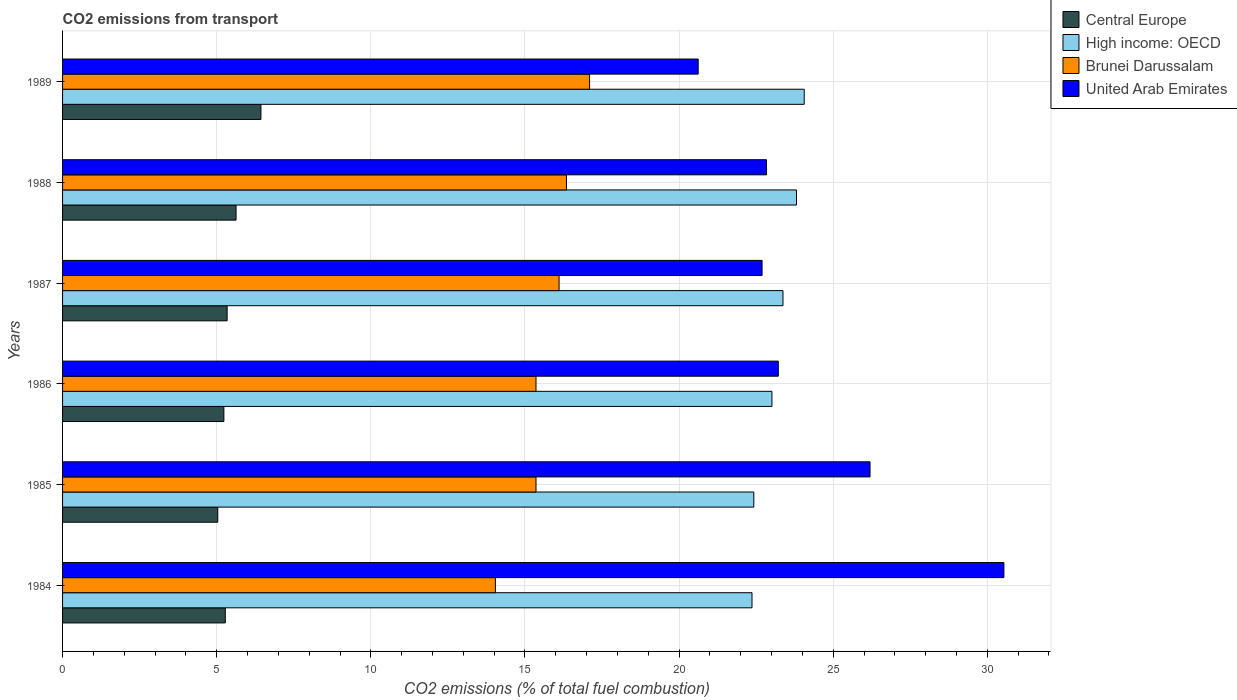How many groups of bars are there?
Make the answer very short. 6. How many bars are there on the 2nd tick from the top?
Your response must be concise. 4. In how many cases, is the number of bars for a given year not equal to the number of legend labels?
Your answer should be very brief. 0. What is the total CO2 emitted in Brunei Darussalam in 1984?
Give a very brief answer. 14.04. Across all years, what is the maximum total CO2 emitted in United Arab Emirates?
Offer a terse response. 30.54. Across all years, what is the minimum total CO2 emitted in High income: OECD?
Keep it short and to the point. 22.37. In which year was the total CO2 emitted in United Arab Emirates minimum?
Offer a terse response. 1989. What is the total total CO2 emitted in Central Europe in the graph?
Provide a succinct answer. 32.95. What is the difference between the total CO2 emitted in United Arab Emirates in 1985 and that in 1989?
Your answer should be very brief. 5.57. What is the difference between the total CO2 emitted in United Arab Emirates in 1988 and the total CO2 emitted in Brunei Darussalam in 1989?
Make the answer very short. 5.74. What is the average total CO2 emitted in Central Europe per year?
Give a very brief answer. 5.49. In the year 1986, what is the difference between the total CO2 emitted in Central Europe and total CO2 emitted in High income: OECD?
Your answer should be compact. -17.78. In how many years, is the total CO2 emitted in United Arab Emirates greater than 20 ?
Your answer should be compact. 6. What is the ratio of the total CO2 emitted in High income: OECD in 1984 to that in 1988?
Keep it short and to the point. 0.94. Is the total CO2 emitted in United Arab Emirates in 1985 less than that in 1987?
Your response must be concise. No. Is the difference between the total CO2 emitted in Central Europe in 1984 and 1988 greater than the difference between the total CO2 emitted in High income: OECD in 1984 and 1988?
Provide a short and direct response. Yes. What is the difference between the highest and the second highest total CO2 emitted in United Arab Emirates?
Provide a short and direct response. 4.34. What is the difference between the highest and the lowest total CO2 emitted in Central Europe?
Provide a succinct answer. 1.4. In how many years, is the total CO2 emitted in Central Europe greater than the average total CO2 emitted in Central Europe taken over all years?
Your response must be concise. 2. Is it the case that in every year, the sum of the total CO2 emitted in High income: OECD and total CO2 emitted in Brunei Darussalam is greater than the sum of total CO2 emitted in Central Europe and total CO2 emitted in United Arab Emirates?
Keep it short and to the point. No. What does the 3rd bar from the top in 1986 represents?
Your answer should be very brief. High income: OECD. What does the 4th bar from the bottom in 1987 represents?
Provide a succinct answer. United Arab Emirates. Is it the case that in every year, the sum of the total CO2 emitted in Central Europe and total CO2 emitted in High income: OECD is greater than the total CO2 emitted in United Arab Emirates?
Your answer should be very brief. No. Are all the bars in the graph horizontal?
Keep it short and to the point. Yes. What is the difference between two consecutive major ticks on the X-axis?
Your answer should be compact. 5. Does the graph contain grids?
Your answer should be very brief. Yes. How many legend labels are there?
Give a very brief answer. 4. What is the title of the graph?
Offer a very short reply. CO2 emissions from transport. What is the label or title of the X-axis?
Offer a terse response. CO2 emissions (% of total fuel combustion). What is the label or title of the Y-axis?
Your response must be concise. Years. What is the CO2 emissions (% of total fuel combustion) of Central Europe in 1984?
Offer a terse response. 5.28. What is the CO2 emissions (% of total fuel combustion) in High income: OECD in 1984?
Your response must be concise. 22.37. What is the CO2 emissions (% of total fuel combustion) in Brunei Darussalam in 1984?
Keep it short and to the point. 14.04. What is the CO2 emissions (% of total fuel combustion) in United Arab Emirates in 1984?
Offer a terse response. 30.54. What is the CO2 emissions (% of total fuel combustion) in Central Europe in 1985?
Make the answer very short. 5.03. What is the CO2 emissions (% of total fuel combustion) in High income: OECD in 1985?
Make the answer very short. 22.42. What is the CO2 emissions (% of total fuel combustion) in Brunei Darussalam in 1985?
Your answer should be very brief. 15.36. What is the CO2 emissions (% of total fuel combustion) of United Arab Emirates in 1985?
Your response must be concise. 26.19. What is the CO2 emissions (% of total fuel combustion) in Central Europe in 1986?
Your answer should be very brief. 5.23. What is the CO2 emissions (% of total fuel combustion) in High income: OECD in 1986?
Ensure brevity in your answer.  23.01. What is the CO2 emissions (% of total fuel combustion) in Brunei Darussalam in 1986?
Give a very brief answer. 15.36. What is the CO2 emissions (% of total fuel combustion) in United Arab Emirates in 1986?
Provide a succinct answer. 23.22. What is the CO2 emissions (% of total fuel combustion) in Central Europe in 1987?
Your response must be concise. 5.34. What is the CO2 emissions (% of total fuel combustion) in High income: OECD in 1987?
Make the answer very short. 23.37. What is the CO2 emissions (% of total fuel combustion) in Brunei Darussalam in 1987?
Give a very brief answer. 16.11. What is the CO2 emissions (% of total fuel combustion) of United Arab Emirates in 1987?
Provide a succinct answer. 22.69. What is the CO2 emissions (% of total fuel combustion) in Central Europe in 1988?
Your response must be concise. 5.63. What is the CO2 emissions (% of total fuel combustion) in High income: OECD in 1988?
Your response must be concise. 23.81. What is the CO2 emissions (% of total fuel combustion) in Brunei Darussalam in 1988?
Provide a short and direct response. 16.35. What is the CO2 emissions (% of total fuel combustion) of United Arab Emirates in 1988?
Offer a very short reply. 22.84. What is the CO2 emissions (% of total fuel combustion) in Central Europe in 1989?
Give a very brief answer. 6.44. What is the CO2 emissions (% of total fuel combustion) in High income: OECD in 1989?
Offer a very short reply. 24.06. What is the CO2 emissions (% of total fuel combustion) in Brunei Darussalam in 1989?
Make the answer very short. 17.1. What is the CO2 emissions (% of total fuel combustion) in United Arab Emirates in 1989?
Provide a succinct answer. 20.62. Across all years, what is the maximum CO2 emissions (% of total fuel combustion) in Central Europe?
Make the answer very short. 6.44. Across all years, what is the maximum CO2 emissions (% of total fuel combustion) in High income: OECD?
Your answer should be very brief. 24.06. Across all years, what is the maximum CO2 emissions (% of total fuel combustion) in Brunei Darussalam?
Provide a succinct answer. 17.1. Across all years, what is the maximum CO2 emissions (% of total fuel combustion) of United Arab Emirates?
Your response must be concise. 30.54. Across all years, what is the minimum CO2 emissions (% of total fuel combustion) of Central Europe?
Your response must be concise. 5.03. Across all years, what is the minimum CO2 emissions (% of total fuel combustion) in High income: OECD?
Provide a succinct answer. 22.37. Across all years, what is the minimum CO2 emissions (% of total fuel combustion) in Brunei Darussalam?
Ensure brevity in your answer.  14.04. Across all years, what is the minimum CO2 emissions (% of total fuel combustion) in United Arab Emirates?
Your answer should be very brief. 20.62. What is the total CO2 emissions (% of total fuel combustion) in Central Europe in the graph?
Offer a terse response. 32.95. What is the total CO2 emissions (% of total fuel combustion) in High income: OECD in the graph?
Give a very brief answer. 139.04. What is the total CO2 emissions (% of total fuel combustion) in Brunei Darussalam in the graph?
Your answer should be very brief. 94.31. What is the total CO2 emissions (% of total fuel combustion) of United Arab Emirates in the graph?
Your answer should be very brief. 146.1. What is the difference between the CO2 emissions (% of total fuel combustion) of Central Europe in 1984 and that in 1985?
Keep it short and to the point. 0.24. What is the difference between the CO2 emissions (% of total fuel combustion) in High income: OECD in 1984 and that in 1985?
Your response must be concise. -0.06. What is the difference between the CO2 emissions (% of total fuel combustion) in Brunei Darussalam in 1984 and that in 1985?
Provide a succinct answer. -1.32. What is the difference between the CO2 emissions (% of total fuel combustion) in United Arab Emirates in 1984 and that in 1985?
Provide a short and direct response. 4.34. What is the difference between the CO2 emissions (% of total fuel combustion) in Central Europe in 1984 and that in 1986?
Your answer should be compact. 0.05. What is the difference between the CO2 emissions (% of total fuel combustion) in High income: OECD in 1984 and that in 1986?
Offer a terse response. -0.65. What is the difference between the CO2 emissions (% of total fuel combustion) in Brunei Darussalam in 1984 and that in 1986?
Provide a short and direct response. -1.32. What is the difference between the CO2 emissions (% of total fuel combustion) in United Arab Emirates in 1984 and that in 1986?
Ensure brevity in your answer.  7.32. What is the difference between the CO2 emissions (% of total fuel combustion) in Central Europe in 1984 and that in 1987?
Offer a very short reply. -0.06. What is the difference between the CO2 emissions (% of total fuel combustion) of High income: OECD in 1984 and that in 1987?
Your response must be concise. -1.01. What is the difference between the CO2 emissions (% of total fuel combustion) of Brunei Darussalam in 1984 and that in 1987?
Your response must be concise. -2.07. What is the difference between the CO2 emissions (% of total fuel combustion) of United Arab Emirates in 1984 and that in 1987?
Provide a succinct answer. 7.84. What is the difference between the CO2 emissions (% of total fuel combustion) in Central Europe in 1984 and that in 1988?
Ensure brevity in your answer.  -0.35. What is the difference between the CO2 emissions (% of total fuel combustion) of High income: OECD in 1984 and that in 1988?
Keep it short and to the point. -1.44. What is the difference between the CO2 emissions (% of total fuel combustion) in Brunei Darussalam in 1984 and that in 1988?
Ensure brevity in your answer.  -2.31. What is the difference between the CO2 emissions (% of total fuel combustion) in United Arab Emirates in 1984 and that in 1988?
Your answer should be compact. 7.7. What is the difference between the CO2 emissions (% of total fuel combustion) in Central Europe in 1984 and that in 1989?
Offer a very short reply. -1.16. What is the difference between the CO2 emissions (% of total fuel combustion) of High income: OECD in 1984 and that in 1989?
Offer a very short reply. -1.69. What is the difference between the CO2 emissions (% of total fuel combustion) of Brunei Darussalam in 1984 and that in 1989?
Make the answer very short. -3.06. What is the difference between the CO2 emissions (% of total fuel combustion) of United Arab Emirates in 1984 and that in 1989?
Your answer should be very brief. 9.92. What is the difference between the CO2 emissions (% of total fuel combustion) of Central Europe in 1985 and that in 1986?
Provide a short and direct response. -0.2. What is the difference between the CO2 emissions (% of total fuel combustion) in High income: OECD in 1985 and that in 1986?
Your response must be concise. -0.59. What is the difference between the CO2 emissions (% of total fuel combustion) of United Arab Emirates in 1985 and that in 1986?
Your answer should be very brief. 2.98. What is the difference between the CO2 emissions (% of total fuel combustion) of Central Europe in 1985 and that in 1987?
Provide a short and direct response. -0.3. What is the difference between the CO2 emissions (% of total fuel combustion) of High income: OECD in 1985 and that in 1987?
Give a very brief answer. -0.95. What is the difference between the CO2 emissions (% of total fuel combustion) in Brunei Darussalam in 1985 and that in 1987?
Provide a succinct answer. -0.75. What is the difference between the CO2 emissions (% of total fuel combustion) of United Arab Emirates in 1985 and that in 1987?
Your answer should be compact. 3.5. What is the difference between the CO2 emissions (% of total fuel combustion) of Central Europe in 1985 and that in 1988?
Give a very brief answer. -0.59. What is the difference between the CO2 emissions (% of total fuel combustion) in High income: OECD in 1985 and that in 1988?
Provide a succinct answer. -1.39. What is the difference between the CO2 emissions (% of total fuel combustion) of Brunei Darussalam in 1985 and that in 1988?
Keep it short and to the point. -0.99. What is the difference between the CO2 emissions (% of total fuel combustion) of United Arab Emirates in 1985 and that in 1988?
Your answer should be compact. 3.36. What is the difference between the CO2 emissions (% of total fuel combustion) in Central Europe in 1985 and that in 1989?
Your response must be concise. -1.4. What is the difference between the CO2 emissions (% of total fuel combustion) of High income: OECD in 1985 and that in 1989?
Offer a very short reply. -1.64. What is the difference between the CO2 emissions (% of total fuel combustion) of Brunei Darussalam in 1985 and that in 1989?
Offer a terse response. -1.74. What is the difference between the CO2 emissions (% of total fuel combustion) of United Arab Emirates in 1985 and that in 1989?
Your answer should be compact. 5.57. What is the difference between the CO2 emissions (% of total fuel combustion) of Central Europe in 1986 and that in 1987?
Give a very brief answer. -0.11. What is the difference between the CO2 emissions (% of total fuel combustion) in High income: OECD in 1986 and that in 1987?
Your answer should be very brief. -0.36. What is the difference between the CO2 emissions (% of total fuel combustion) of Brunei Darussalam in 1986 and that in 1987?
Provide a succinct answer. -0.75. What is the difference between the CO2 emissions (% of total fuel combustion) in United Arab Emirates in 1986 and that in 1987?
Make the answer very short. 0.53. What is the difference between the CO2 emissions (% of total fuel combustion) of Central Europe in 1986 and that in 1988?
Make the answer very short. -0.4. What is the difference between the CO2 emissions (% of total fuel combustion) in High income: OECD in 1986 and that in 1988?
Provide a short and direct response. -0.8. What is the difference between the CO2 emissions (% of total fuel combustion) of Brunei Darussalam in 1986 and that in 1988?
Your answer should be compact. -0.99. What is the difference between the CO2 emissions (% of total fuel combustion) of United Arab Emirates in 1986 and that in 1988?
Provide a succinct answer. 0.38. What is the difference between the CO2 emissions (% of total fuel combustion) in Central Europe in 1986 and that in 1989?
Offer a terse response. -1.2. What is the difference between the CO2 emissions (% of total fuel combustion) of High income: OECD in 1986 and that in 1989?
Provide a short and direct response. -1.05. What is the difference between the CO2 emissions (% of total fuel combustion) of Brunei Darussalam in 1986 and that in 1989?
Keep it short and to the point. -1.74. What is the difference between the CO2 emissions (% of total fuel combustion) of United Arab Emirates in 1986 and that in 1989?
Provide a short and direct response. 2.6. What is the difference between the CO2 emissions (% of total fuel combustion) in Central Europe in 1987 and that in 1988?
Make the answer very short. -0.29. What is the difference between the CO2 emissions (% of total fuel combustion) of High income: OECD in 1987 and that in 1988?
Offer a terse response. -0.44. What is the difference between the CO2 emissions (% of total fuel combustion) of Brunei Darussalam in 1987 and that in 1988?
Your answer should be compact. -0.24. What is the difference between the CO2 emissions (% of total fuel combustion) of United Arab Emirates in 1987 and that in 1988?
Keep it short and to the point. -0.14. What is the difference between the CO2 emissions (% of total fuel combustion) of Central Europe in 1987 and that in 1989?
Give a very brief answer. -1.1. What is the difference between the CO2 emissions (% of total fuel combustion) of High income: OECD in 1987 and that in 1989?
Give a very brief answer. -0.69. What is the difference between the CO2 emissions (% of total fuel combustion) of Brunei Darussalam in 1987 and that in 1989?
Provide a short and direct response. -0.99. What is the difference between the CO2 emissions (% of total fuel combustion) of United Arab Emirates in 1987 and that in 1989?
Give a very brief answer. 2.07. What is the difference between the CO2 emissions (% of total fuel combustion) of Central Europe in 1988 and that in 1989?
Make the answer very short. -0.81. What is the difference between the CO2 emissions (% of total fuel combustion) in High income: OECD in 1988 and that in 1989?
Ensure brevity in your answer.  -0.25. What is the difference between the CO2 emissions (% of total fuel combustion) in Brunei Darussalam in 1988 and that in 1989?
Provide a short and direct response. -0.75. What is the difference between the CO2 emissions (% of total fuel combustion) of United Arab Emirates in 1988 and that in 1989?
Ensure brevity in your answer.  2.22. What is the difference between the CO2 emissions (% of total fuel combustion) of Central Europe in 1984 and the CO2 emissions (% of total fuel combustion) of High income: OECD in 1985?
Your response must be concise. -17.15. What is the difference between the CO2 emissions (% of total fuel combustion) of Central Europe in 1984 and the CO2 emissions (% of total fuel combustion) of Brunei Darussalam in 1985?
Your response must be concise. -10.08. What is the difference between the CO2 emissions (% of total fuel combustion) in Central Europe in 1984 and the CO2 emissions (% of total fuel combustion) in United Arab Emirates in 1985?
Your answer should be compact. -20.92. What is the difference between the CO2 emissions (% of total fuel combustion) in High income: OECD in 1984 and the CO2 emissions (% of total fuel combustion) in Brunei Darussalam in 1985?
Keep it short and to the point. 7.01. What is the difference between the CO2 emissions (% of total fuel combustion) of High income: OECD in 1984 and the CO2 emissions (% of total fuel combustion) of United Arab Emirates in 1985?
Your answer should be very brief. -3.83. What is the difference between the CO2 emissions (% of total fuel combustion) of Brunei Darussalam in 1984 and the CO2 emissions (% of total fuel combustion) of United Arab Emirates in 1985?
Provide a short and direct response. -12.15. What is the difference between the CO2 emissions (% of total fuel combustion) of Central Europe in 1984 and the CO2 emissions (% of total fuel combustion) of High income: OECD in 1986?
Your response must be concise. -17.73. What is the difference between the CO2 emissions (% of total fuel combustion) in Central Europe in 1984 and the CO2 emissions (% of total fuel combustion) in Brunei Darussalam in 1986?
Your answer should be compact. -10.08. What is the difference between the CO2 emissions (% of total fuel combustion) in Central Europe in 1984 and the CO2 emissions (% of total fuel combustion) in United Arab Emirates in 1986?
Make the answer very short. -17.94. What is the difference between the CO2 emissions (% of total fuel combustion) in High income: OECD in 1984 and the CO2 emissions (% of total fuel combustion) in Brunei Darussalam in 1986?
Your answer should be compact. 7.01. What is the difference between the CO2 emissions (% of total fuel combustion) in High income: OECD in 1984 and the CO2 emissions (% of total fuel combustion) in United Arab Emirates in 1986?
Provide a succinct answer. -0.85. What is the difference between the CO2 emissions (% of total fuel combustion) in Brunei Darussalam in 1984 and the CO2 emissions (% of total fuel combustion) in United Arab Emirates in 1986?
Ensure brevity in your answer.  -9.18. What is the difference between the CO2 emissions (% of total fuel combustion) in Central Europe in 1984 and the CO2 emissions (% of total fuel combustion) in High income: OECD in 1987?
Your answer should be compact. -18.09. What is the difference between the CO2 emissions (% of total fuel combustion) of Central Europe in 1984 and the CO2 emissions (% of total fuel combustion) of Brunei Darussalam in 1987?
Ensure brevity in your answer.  -10.83. What is the difference between the CO2 emissions (% of total fuel combustion) in Central Europe in 1984 and the CO2 emissions (% of total fuel combustion) in United Arab Emirates in 1987?
Your answer should be compact. -17.41. What is the difference between the CO2 emissions (% of total fuel combustion) of High income: OECD in 1984 and the CO2 emissions (% of total fuel combustion) of Brunei Darussalam in 1987?
Ensure brevity in your answer.  6.26. What is the difference between the CO2 emissions (% of total fuel combustion) of High income: OECD in 1984 and the CO2 emissions (% of total fuel combustion) of United Arab Emirates in 1987?
Your response must be concise. -0.33. What is the difference between the CO2 emissions (% of total fuel combustion) in Brunei Darussalam in 1984 and the CO2 emissions (% of total fuel combustion) in United Arab Emirates in 1987?
Your answer should be very brief. -8.65. What is the difference between the CO2 emissions (% of total fuel combustion) of Central Europe in 1984 and the CO2 emissions (% of total fuel combustion) of High income: OECD in 1988?
Offer a terse response. -18.53. What is the difference between the CO2 emissions (% of total fuel combustion) in Central Europe in 1984 and the CO2 emissions (% of total fuel combustion) in Brunei Darussalam in 1988?
Give a very brief answer. -11.07. What is the difference between the CO2 emissions (% of total fuel combustion) of Central Europe in 1984 and the CO2 emissions (% of total fuel combustion) of United Arab Emirates in 1988?
Ensure brevity in your answer.  -17.56. What is the difference between the CO2 emissions (% of total fuel combustion) of High income: OECD in 1984 and the CO2 emissions (% of total fuel combustion) of Brunei Darussalam in 1988?
Your answer should be very brief. 6.02. What is the difference between the CO2 emissions (% of total fuel combustion) of High income: OECD in 1984 and the CO2 emissions (% of total fuel combustion) of United Arab Emirates in 1988?
Keep it short and to the point. -0.47. What is the difference between the CO2 emissions (% of total fuel combustion) in Brunei Darussalam in 1984 and the CO2 emissions (% of total fuel combustion) in United Arab Emirates in 1988?
Your answer should be compact. -8.8. What is the difference between the CO2 emissions (% of total fuel combustion) of Central Europe in 1984 and the CO2 emissions (% of total fuel combustion) of High income: OECD in 1989?
Provide a short and direct response. -18.78. What is the difference between the CO2 emissions (% of total fuel combustion) in Central Europe in 1984 and the CO2 emissions (% of total fuel combustion) in Brunei Darussalam in 1989?
Your answer should be compact. -11.82. What is the difference between the CO2 emissions (% of total fuel combustion) of Central Europe in 1984 and the CO2 emissions (% of total fuel combustion) of United Arab Emirates in 1989?
Your response must be concise. -15.34. What is the difference between the CO2 emissions (% of total fuel combustion) in High income: OECD in 1984 and the CO2 emissions (% of total fuel combustion) in Brunei Darussalam in 1989?
Offer a very short reply. 5.27. What is the difference between the CO2 emissions (% of total fuel combustion) in High income: OECD in 1984 and the CO2 emissions (% of total fuel combustion) in United Arab Emirates in 1989?
Your answer should be compact. 1.75. What is the difference between the CO2 emissions (% of total fuel combustion) of Brunei Darussalam in 1984 and the CO2 emissions (% of total fuel combustion) of United Arab Emirates in 1989?
Your answer should be compact. -6.58. What is the difference between the CO2 emissions (% of total fuel combustion) of Central Europe in 1985 and the CO2 emissions (% of total fuel combustion) of High income: OECD in 1986?
Your response must be concise. -17.98. What is the difference between the CO2 emissions (% of total fuel combustion) of Central Europe in 1985 and the CO2 emissions (% of total fuel combustion) of Brunei Darussalam in 1986?
Ensure brevity in your answer.  -10.32. What is the difference between the CO2 emissions (% of total fuel combustion) of Central Europe in 1985 and the CO2 emissions (% of total fuel combustion) of United Arab Emirates in 1986?
Offer a very short reply. -18.18. What is the difference between the CO2 emissions (% of total fuel combustion) in High income: OECD in 1985 and the CO2 emissions (% of total fuel combustion) in Brunei Darussalam in 1986?
Your answer should be compact. 7.07. What is the difference between the CO2 emissions (% of total fuel combustion) of High income: OECD in 1985 and the CO2 emissions (% of total fuel combustion) of United Arab Emirates in 1986?
Give a very brief answer. -0.79. What is the difference between the CO2 emissions (% of total fuel combustion) in Brunei Darussalam in 1985 and the CO2 emissions (% of total fuel combustion) in United Arab Emirates in 1986?
Provide a short and direct response. -7.86. What is the difference between the CO2 emissions (% of total fuel combustion) of Central Europe in 1985 and the CO2 emissions (% of total fuel combustion) of High income: OECD in 1987?
Offer a terse response. -18.34. What is the difference between the CO2 emissions (% of total fuel combustion) in Central Europe in 1985 and the CO2 emissions (% of total fuel combustion) in Brunei Darussalam in 1987?
Your response must be concise. -11.07. What is the difference between the CO2 emissions (% of total fuel combustion) in Central Europe in 1985 and the CO2 emissions (% of total fuel combustion) in United Arab Emirates in 1987?
Give a very brief answer. -17.66. What is the difference between the CO2 emissions (% of total fuel combustion) of High income: OECD in 1985 and the CO2 emissions (% of total fuel combustion) of Brunei Darussalam in 1987?
Your answer should be compact. 6.32. What is the difference between the CO2 emissions (% of total fuel combustion) in High income: OECD in 1985 and the CO2 emissions (% of total fuel combustion) in United Arab Emirates in 1987?
Provide a short and direct response. -0.27. What is the difference between the CO2 emissions (% of total fuel combustion) in Brunei Darussalam in 1985 and the CO2 emissions (% of total fuel combustion) in United Arab Emirates in 1987?
Provide a succinct answer. -7.33. What is the difference between the CO2 emissions (% of total fuel combustion) in Central Europe in 1985 and the CO2 emissions (% of total fuel combustion) in High income: OECD in 1988?
Give a very brief answer. -18.77. What is the difference between the CO2 emissions (% of total fuel combustion) in Central Europe in 1985 and the CO2 emissions (% of total fuel combustion) in Brunei Darussalam in 1988?
Keep it short and to the point. -11.31. What is the difference between the CO2 emissions (% of total fuel combustion) in Central Europe in 1985 and the CO2 emissions (% of total fuel combustion) in United Arab Emirates in 1988?
Keep it short and to the point. -17.8. What is the difference between the CO2 emissions (% of total fuel combustion) of High income: OECD in 1985 and the CO2 emissions (% of total fuel combustion) of Brunei Darussalam in 1988?
Your answer should be compact. 6.08. What is the difference between the CO2 emissions (% of total fuel combustion) in High income: OECD in 1985 and the CO2 emissions (% of total fuel combustion) in United Arab Emirates in 1988?
Offer a terse response. -0.41. What is the difference between the CO2 emissions (% of total fuel combustion) of Brunei Darussalam in 1985 and the CO2 emissions (% of total fuel combustion) of United Arab Emirates in 1988?
Give a very brief answer. -7.48. What is the difference between the CO2 emissions (% of total fuel combustion) of Central Europe in 1985 and the CO2 emissions (% of total fuel combustion) of High income: OECD in 1989?
Make the answer very short. -19.02. What is the difference between the CO2 emissions (% of total fuel combustion) in Central Europe in 1985 and the CO2 emissions (% of total fuel combustion) in Brunei Darussalam in 1989?
Provide a succinct answer. -12.06. What is the difference between the CO2 emissions (% of total fuel combustion) in Central Europe in 1985 and the CO2 emissions (% of total fuel combustion) in United Arab Emirates in 1989?
Your answer should be very brief. -15.59. What is the difference between the CO2 emissions (% of total fuel combustion) in High income: OECD in 1985 and the CO2 emissions (% of total fuel combustion) in Brunei Darussalam in 1989?
Your answer should be compact. 5.33. What is the difference between the CO2 emissions (% of total fuel combustion) in High income: OECD in 1985 and the CO2 emissions (% of total fuel combustion) in United Arab Emirates in 1989?
Ensure brevity in your answer.  1.8. What is the difference between the CO2 emissions (% of total fuel combustion) in Brunei Darussalam in 1985 and the CO2 emissions (% of total fuel combustion) in United Arab Emirates in 1989?
Provide a succinct answer. -5.26. What is the difference between the CO2 emissions (% of total fuel combustion) of Central Europe in 1986 and the CO2 emissions (% of total fuel combustion) of High income: OECD in 1987?
Your response must be concise. -18.14. What is the difference between the CO2 emissions (% of total fuel combustion) in Central Europe in 1986 and the CO2 emissions (% of total fuel combustion) in Brunei Darussalam in 1987?
Keep it short and to the point. -10.87. What is the difference between the CO2 emissions (% of total fuel combustion) in Central Europe in 1986 and the CO2 emissions (% of total fuel combustion) in United Arab Emirates in 1987?
Offer a terse response. -17.46. What is the difference between the CO2 emissions (% of total fuel combustion) in High income: OECD in 1986 and the CO2 emissions (% of total fuel combustion) in Brunei Darussalam in 1987?
Ensure brevity in your answer.  6.9. What is the difference between the CO2 emissions (% of total fuel combustion) of High income: OECD in 1986 and the CO2 emissions (% of total fuel combustion) of United Arab Emirates in 1987?
Your response must be concise. 0.32. What is the difference between the CO2 emissions (% of total fuel combustion) in Brunei Darussalam in 1986 and the CO2 emissions (% of total fuel combustion) in United Arab Emirates in 1987?
Keep it short and to the point. -7.33. What is the difference between the CO2 emissions (% of total fuel combustion) in Central Europe in 1986 and the CO2 emissions (% of total fuel combustion) in High income: OECD in 1988?
Offer a terse response. -18.58. What is the difference between the CO2 emissions (% of total fuel combustion) in Central Europe in 1986 and the CO2 emissions (% of total fuel combustion) in Brunei Darussalam in 1988?
Your answer should be very brief. -11.11. What is the difference between the CO2 emissions (% of total fuel combustion) of Central Europe in 1986 and the CO2 emissions (% of total fuel combustion) of United Arab Emirates in 1988?
Make the answer very short. -17.6. What is the difference between the CO2 emissions (% of total fuel combustion) in High income: OECD in 1986 and the CO2 emissions (% of total fuel combustion) in Brunei Darussalam in 1988?
Offer a very short reply. 6.67. What is the difference between the CO2 emissions (% of total fuel combustion) in High income: OECD in 1986 and the CO2 emissions (% of total fuel combustion) in United Arab Emirates in 1988?
Offer a very short reply. 0.18. What is the difference between the CO2 emissions (% of total fuel combustion) in Brunei Darussalam in 1986 and the CO2 emissions (% of total fuel combustion) in United Arab Emirates in 1988?
Give a very brief answer. -7.48. What is the difference between the CO2 emissions (% of total fuel combustion) of Central Europe in 1986 and the CO2 emissions (% of total fuel combustion) of High income: OECD in 1989?
Offer a very short reply. -18.83. What is the difference between the CO2 emissions (% of total fuel combustion) of Central Europe in 1986 and the CO2 emissions (% of total fuel combustion) of Brunei Darussalam in 1989?
Your answer should be compact. -11.86. What is the difference between the CO2 emissions (% of total fuel combustion) in Central Europe in 1986 and the CO2 emissions (% of total fuel combustion) in United Arab Emirates in 1989?
Offer a very short reply. -15.39. What is the difference between the CO2 emissions (% of total fuel combustion) of High income: OECD in 1986 and the CO2 emissions (% of total fuel combustion) of Brunei Darussalam in 1989?
Your answer should be compact. 5.92. What is the difference between the CO2 emissions (% of total fuel combustion) in High income: OECD in 1986 and the CO2 emissions (% of total fuel combustion) in United Arab Emirates in 1989?
Your answer should be compact. 2.39. What is the difference between the CO2 emissions (% of total fuel combustion) in Brunei Darussalam in 1986 and the CO2 emissions (% of total fuel combustion) in United Arab Emirates in 1989?
Make the answer very short. -5.26. What is the difference between the CO2 emissions (% of total fuel combustion) in Central Europe in 1987 and the CO2 emissions (% of total fuel combustion) in High income: OECD in 1988?
Provide a short and direct response. -18.47. What is the difference between the CO2 emissions (% of total fuel combustion) of Central Europe in 1987 and the CO2 emissions (% of total fuel combustion) of Brunei Darussalam in 1988?
Offer a terse response. -11.01. What is the difference between the CO2 emissions (% of total fuel combustion) of Central Europe in 1987 and the CO2 emissions (% of total fuel combustion) of United Arab Emirates in 1988?
Give a very brief answer. -17.5. What is the difference between the CO2 emissions (% of total fuel combustion) of High income: OECD in 1987 and the CO2 emissions (% of total fuel combustion) of Brunei Darussalam in 1988?
Give a very brief answer. 7.02. What is the difference between the CO2 emissions (% of total fuel combustion) in High income: OECD in 1987 and the CO2 emissions (% of total fuel combustion) in United Arab Emirates in 1988?
Offer a very short reply. 0.53. What is the difference between the CO2 emissions (% of total fuel combustion) of Brunei Darussalam in 1987 and the CO2 emissions (% of total fuel combustion) of United Arab Emirates in 1988?
Offer a terse response. -6.73. What is the difference between the CO2 emissions (% of total fuel combustion) in Central Europe in 1987 and the CO2 emissions (% of total fuel combustion) in High income: OECD in 1989?
Offer a very short reply. -18.72. What is the difference between the CO2 emissions (% of total fuel combustion) in Central Europe in 1987 and the CO2 emissions (% of total fuel combustion) in Brunei Darussalam in 1989?
Offer a very short reply. -11.76. What is the difference between the CO2 emissions (% of total fuel combustion) of Central Europe in 1987 and the CO2 emissions (% of total fuel combustion) of United Arab Emirates in 1989?
Your answer should be compact. -15.28. What is the difference between the CO2 emissions (% of total fuel combustion) of High income: OECD in 1987 and the CO2 emissions (% of total fuel combustion) of Brunei Darussalam in 1989?
Make the answer very short. 6.27. What is the difference between the CO2 emissions (% of total fuel combustion) of High income: OECD in 1987 and the CO2 emissions (% of total fuel combustion) of United Arab Emirates in 1989?
Your response must be concise. 2.75. What is the difference between the CO2 emissions (% of total fuel combustion) in Brunei Darussalam in 1987 and the CO2 emissions (% of total fuel combustion) in United Arab Emirates in 1989?
Make the answer very short. -4.51. What is the difference between the CO2 emissions (% of total fuel combustion) of Central Europe in 1988 and the CO2 emissions (% of total fuel combustion) of High income: OECD in 1989?
Your answer should be compact. -18.43. What is the difference between the CO2 emissions (% of total fuel combustion) of Central Europe in 1988 and the CO2 emissions (% of total fuel combustion) of Brunei Darussalam in 1989?
Give a very brief answer. -11.47. What is the difference between the CO2 emissions (% of total fuel combustion) in Central Europe in 1988 and the CO2 emissions (% of total fuel combustion) in United Arab Emirates in 1989?
Your answer should be very brief. -14.99. What is the difference between the CO2 emissions (% of total fuel combustion) in High income: OECD in 1988 and the CO2 emissions (% of total fuel combustion) in Brunei Darussalam in 1989?
Ensure brevity in your answer.  6.71. What is the difference between the CO2 emissions (% of total fuel combustion) of High income: OECD in 1988 and the CO2 emissions (% of total fuel combustion) of United Arab Emirates in 1989?
Offer a very short reply. 3.19. What is the difference between the CO2 emissions (% of total fuel combustion) of Brunei Darussalam in 1988 and the CO2 emissions (% of total fuel combustion) of United Arab Emirates in 1989?
Your response must be concise. -4.27. What is the average CO2 emissions (% of total fuel combustion) of Central Europe per year?
Your answer should be compact. 5.49. What is the average CO2 emissions (% of total fuel combustion) in High income: OECD per year?
Offer a very short reply. 23.17. What is the average CO2 emissions (% of total fuel combustion) of Brunei Darussalam per year?
Provide a short and direct response. 15.72. What is the average CO2 emissions (% of total fuel combustion) of United Arab Emirates per year?
Provide a succinct answer. 24.35. In the year 1984, what is the difference between the CO2 emissions (% of total fuel combustion) in Central Europe and CO2 emissions (% of total fuel combustion) in High income: OECD?
Your response must be concise. -17.09. In the year 1984, what is the difference between the CO2 emissions (% of total fuel combustion) in Central Europe and CO2 emissions (% of total fuel combustion) in Brunei Darussalam?
Offer a very short reply. -8.76. In the year 1984, what is the difference between the CO2 emissions (% of total fuel combustion) in Central Europe and CO2 emissions (% of total fuel combustion) in United Arab Emirates?
Your response must be concise. -25.26. In the year 1984, what is the difference between the CO2 emissions (% of total fuel combustion) in High income: OECD and CO2 emissions (% of total fuel combustion) in Brunei Darussalam?
Provide a succinct answer. 8.32. In the year 1984, what is the difference between the CO2 emissions (% of total fuel combustion) of High income: OECD and CO2 emissions (% of total fuel combustion) of United Arab Emirates?
Your answer should be compact. -8.17. In the year 1984, what is the difference between the CO2 emissions (% of total fuel combustion) of Brunei Darussalam and CO2 emissions (% of total fuel combustion) of United Arab Emirates?
Provide a succinct answer. -16.5. In the year 1985, what is the difference between the CO2 emissions (% of total fuel combustion) of Central Europe and CO2 emissions (% of total fuel combustion) of High income: OECD?
Provide a short and direct response. -17.39. In the year 1985, what is the difference between the CO2 emissions (% of total fuel combustion) of Central Europe and CO2 emissions (% of total fuel combustion) of Brunei Darussalam?
Provide a succinct answer. -10.32. In the year 1985, what is the difference between the CO2 emissions (% of total fuel combustion) in Central Europe and CO2 emissions (% of total fuel combustion) in United Arab Emirates?
Offer a terse response. -21.16. In the year 1985, what is the difference between the CO2 emissions (% of total fuel combustion) in High income: OECD and CO2 emissions (% of total fuel combustion) in Brunei Darussalam?
Make the answer very short. 7.07. In the year 1985, what is the difference between the CO2 emissions (% of total fuel combustion) in High income: OECD and CO2 emissions (% of total fuel combustion) in United Arab Emirates?
Your response must be concise. -3.77. In the year 1985, what is the difference between the CO2 emissions (% of total fuel combustion) of Brunei Darussalam and CO2 emissions (% of total fuel combustion) of United Arab Emirates?
Make the answer very short. -10.84. In the year 1986, what is the difference between the CO2 emissions (% of total fuel combustion) of Central Europe and CO2 emissions (% of total fuel combustion) of High income: OECD?
Keep it short and to the point. -17.78. In the year 1986, what is the difference between the CO2 emissions (% of total fuel combustion) in Central Europe and CO2 emissions (% of total fuel combustion) in Brunei Darussalam?
Your response must be concise. -10.13. In the year 1986, what is the difference between the CO2 emissions (% of total fuel combustion) in Central Europe and CO2 emissions (% of total fuel combustion) in United Arab Emirates?
Your response must be concise. -17.99. In the year 1986, what is the difference between the CO2 emissions (% of total fuel combustion) of High income: OECD and CO2 emissions (% of total fuel combustion) of Brunei Darussalam?
Your response must be concise. 7.65. In the year 1986, what is the difference between the CO2 emissions (% of total fuel combustion) of High income: OECD and CO2 emissions (% of total fuel combustion) of United Arab Emirates?
Your answer should be very brief. -0.21. In the year 1986, what is the difference between the CO2 emissions (% of total fuel combustion) of Brunei Darussalam and CO2 emissions (% of total fuel combustion) of United Arab Emirates?
Ensure brevity in your answer.  -7.86. In the year 1987, what is the difference between the CO2 emissions (% of total fuel combustion) of Central Europe and CO2 emissions (% of total fuel combustion) of High income: OECD?
Give a very brief answer. -18.03. In the year 1987, what is the difference between the CO2 emissions (% of total fuel combustion) of Central Europe and CO2 emissions (% of total fuel combustion) of Brunei Darussalam?
Provide a short and direct response. -10.77. In the year 1987, what is the difference between the CO2 emissions (% of total fuel combustion) of Central Europe and CO2 emissions (% of total fuel combustion) of United Arab Emirates?
Your response must be concise. -17.35. In the year 1987, what is the difference between the CO2 emissions (% of total fuel combustion) in High income: OECD and CO2 emissions (% of total fuel combustion) in Brunei Darussalam?
Make the answer very short. 7.26. In the year 1987, what is the difference between the CO2 emissions (% of total fuel combustion) of High income: OECD and CO2 emissions (% of total fuel combustion) of United Arab Emirates?
Your response must be concise. 0.68. In the year 1987, what is the difference between the CO2 emissions (% of total fuel combustion) of Brunei Darussalam and CO2 emissions (% of total fuel combustion) of United Arab Emirates?
Provide a succinct answer. -6.58. In the year 1988, what is the difference between the CO2 emissions (% of total fuel combustion) of Central Europe and CO2 emissions (% of total fuel combustion) of High income: OECD?
Provide a succinct answer. -18.18. In the year 1988, what is the difference between the CO2 emissions (% of total fuel combustion) of Central Europe and CO2 emissions (% of total fuel combustion) of Brunei Darussalam?
Give a very brief answer. -10.72. In the year 1988, what is the difference between the CO2 emissions (% of total fuel combustion) in Central Europe and CO2 emissions (% of total fuel combustion) in United Arab Emirates?
Provide a succinct answer. -17.21. In the year 1988, what is the difference between the CO2 emissions (% of total fuel combustion) of High income: OECD and CO2 emissions (% of total fuel combustion) of Brunei Darussalam?
Offer a very short reply. 7.46. In the year 1988, what is the difference between the CO2 emissions (% of total fuel combustion) of High income: OECD and CO2 emissions (% of total fuel combustion) of United Arab Emirates?
Give a very brief answer. 0.97. In the year 1988, what is the difference between the CO2 emissions (% of total fuel combustion) of Brunei Darussalam and CO2 emissions (% of total fuel combustion) of United Arab Emirates?
Offer a terse response. -6.49. In the year 1989, what is the difference between the CO2 emissions (% of total fuel combustion) in Central Europe and CO2 emissions (% of total fuel combustion) in High income: OECD?
Your response must be concise. -17.62. In the year 1989, what is the difference between the CO2 emissions (% of total fuel combustion) in Central Europe and CO2 emissions (% of total fuel combustion) in Brunei Darussalam?
Your answer should be compact. -10.66. In the year 1989, what is the difference between the CO2 emissions (% of total fuel combustion) in Central Europe and CO2 emissions (% of total fuel combustion) in United Arab Emirates?
Your response must be concise. -14.18. In the year 1989, what is the difference between the CO2 emissions (% of total fuel combustion) in High income: OECD and CO2 emissions (% of total fuel combustion) in Brunei Darussalam?
Offer a terse response. 6.96. In the year 1989, what is the difference between the CO2 emissions (% of total fuel combustion) in High income: OECD and CO2 emissions (% of total fuel combustion) in United Arab Emirates?
Offer a terse response. 3.44. In the year 1989, what is the difference between the CO2 emissions (% of total fuel combustion) in Brunei Darussalam and CO2 emissions (% of total fuel combustion) in United Arab Emirates?
Ensure brevity in your answer.  -3.52. What is the ratio of the CO2 emissions (% of total fuel combustion) of Central Europe in 1984 to that in 1985?
Keep it short and to the point. 1.05. What is the ratio of the CO2 emissions (% of total fuel combustion) in Brunei Darussalam in 1984 to that in 1985?
Give a very brief answer. 0.91. What is the ratio of the CO2 emissions (% of total fuel combustion) of United Arab Emirates in 1984 to that in 1985?
Offer a very short reply. 1.17. What is the ratio of the CO2 emissions (% of total fuel combustion) in Central Europe in 1984 to that in 1986?
Make the answer very short. 1.01. What is the ratio of the CO2 emissions (% of total fuel combustion) of High income: OECD in 1984 to that in 1986?
Make the answer very short. 0.97. What is the ratio of the CO2 emissions (% of total fuel combustion) in Brunei Darussalam in 1984 to that in 1986?
Offer a terse response. 0.91. What is the ratio of the CO2 emissions (% of total fuel combustion) in United Arab Emirates in 1984 to that in 1986?
Ensure brevity in your answer.  1.32. What is the ratio of the CO2 emissions (% of total fuel combustion) of Central Europe in 1984 to that in 1987?
Keep it short and to the point. 0.99. What is the ratio of the CO2 emissions (% of total fuel combustion) of Brunei Darussalam in 1984 to that in 1987?
Ensure brevity in your answer.  0.87. What is the ratio of the CO2 emissions (% of total fuel combustion) in United Arab Emirates in 1984 to that in 1987?
Offer a terse response. 1.35. What is the ratio of the CO2 emissions (% of total fuel combustion) in Central Europe in 1984 to that in 1988?
Offer a terse response. 0.94. What is the ratio of the CO2 emissions (% of total fuel combustion) in High income: OECD in 1984 to that in 1988?
Offer a terse response. 0.94. What is the ratio of the CO2 emissions (% of total fuel combustion) in Brunei Darussalam in 1984 to that in 1988?
Your response must be concise. 0.86. What is the ratio of the CO2 emissions (% of total fuel combustion) of United Arab Emirates in 1984 to that in 1988?
Your answer should be very brief. 1.34. What is the ratio of the CO2 emissions (% of total fuel combustion) of Central Europe in 1984 to that in 1989?
Provide a succinct answer. 0.82. What is the ratio of the CO2 emissions (% of total fuel combustion) of High income: OECD in 1984 to that in 1989?
Provide a succinct answer. 0.93. What is the ratio of the CO2 emissions (% of total fuel combustion) of Brunei Darussalam in 1984 to that in 1989?
Offer a terse response. 0.82. What is the ratio of the CO2 emissions (% of total fuel combustion) of United Arab Emirates in 1984 to that in 1989?
Give a very brief answer. 1.48. What is the ratio of the CO2 emissions (% of total fuel combustion) in Central Europe in 1985 to that in 1986?
Ensure brevity in your answer.  0.96. What is the ratio of the CO2 emissions (% of total fuel combustion) of High income: OECD in 1985 to that in 1986?
Your answer should be compact. 0.97. What is the ratio of the CO2 emissions (% of total fuel combustion) in United Arab Emirates in 1985 to that in 1986?
Provide a succinct answer. 1.13. What is the ratio of the CO2 emissions (% of total fuel combustion) of Central Europe in 1985 to that in 1987?
Make the answer very short. 0.94. What is the ratio of the CO2 emissions (% of total fuel combustion) of High income: OECD in 1985 to that in 1987?
Your answer should be very brief. 0.96. What is the ratio of the CO2 emissions (% of total fuel combustion) in Brunei Darussalam in 1985 to that in 1987?
Provide a succinct answer. 0.95. What is the ratio of the CO2 emissions (% of total fuel combustion) in United Arab Emirates in 1985 to that in 1987?
Offer a terse response. 1.15. What is the ratio of the CO2 emissions (% of total fuel combustion) of Central Europe in 1985 to that in 1988?
Your response must be concise. 0.89. What is the ratio of the CO2 emissions (% of total fuel combustion) in High income: OECD in 1985 to that in 1988?
Your response must be concise. 0.94. What is the ratio of the CO2 emissions (% of total fuel combustion) of Brunei Darussalam in 1985 to that in 1988?
Ensure brevity in your answer.  0.94. What is the ratio of the CO2 emissions (% of total fuel combustion) of United Arab Emirates in 1985 to that in 1988?
Provide a succinct answer. 1.15. What is the ratio of the CO2 emissions (% of total fuel combustion) of Central Europe in 1985 to that in 1989?
Offer a terse response. 0.78. What is the ratio of the CO2 emissions (% of total fuel combustion) in High income: OECD in 1985 to that in 1989?
Offer a very short reply. 0.93. What is the ratio of the CO2 emissions (% of total fuel combustion) in Brunei Darussalam in 1985 to that in 1989?
Give a very brief answer. 0.9. What is the ratio of the CO2 emissions (% of total fuel combustion) of United Arab Emirates in 1985 to that in 1989?
Your answer should be compact. 1.27. What is the ratio of the CO2 emissions (% of total fuel combustion) in Central Europe in 1986 to that in 1987?
Provide a short and direct response. 0.98. What is the ratio of the CO2 emissions (% of total fuel combustion) in High income: OECD in 1986 to that in 1987?
Provide a succinct answer. 0.98. What is the ratio of the CO2 emissions (% of total fuel combustion) of Brunei Darussalam in 1986 to that in 1987?
Provide a short and direct response. 0.95. What is the ratio of the CO2 emissions (% of total fuel combustion) in United Arab Emirates in 1986 to that in 1987?
Provide a short and direct response. 1.02. What is the ratio of the CO2 emissions (% of total fuel combustion) in Central Europe in 1986 to that in 1988?
Provide a succinct answer. 0.93. What is the ratio of the CO2 emissions (% of total fuel combustion) of High income: OECD in 1986 to that in 1988?
Make the answer very short. 0.97. What is the ratio of the CO2 emissions (% of total fuel combustion) in Brunei Darussalam in 1986 to that in 1988?
Provide a short and direct response. 0.94. What is the ratio of the CO2 emissions (% of total fuel combustion) in United Arab Emirates in 1986 to that in 1988?
Give a very brief answer. 1.02. What is the ratio of the CO2 emissions (% of total fuel combustion) of Central Europe in 1986 to that in 1989?
Offer a terse response. 0.81. What is the ratio of the CO2 emissions (% of total fuel combustion) of High income: OECD in 1986 to that in 1989?
Provide a succinct answer. 0.96. What is the ratio of the CO2 emissions (% of total fuel combustion) of Brunei Darussalam in 1986 to that in 1989?
Keep it short and to the point. 0.9. What is the ratio of the CO2 emissions (% of total fuel combustion) of United Arab Emirates in 1986 to that in 1989?
Your response must be concise. 1.13. What is the ratio of the CO2 emissions (% of total fuel combustion) of Central Europe in 1987 to that in 1988?
Ensure brevity in your answer.  0.95. What is the ratio of the CO2 emissions (% of total fuel combustion) in High income: OECD in 1987 to that in 1988?
Provide a short and direct response. 0.98. What is the ratio of the CO2 emissions (% of total fuel combustion) of Brunei Darussalam in 1987 to that in 1988?
Provide a succinct answer. 0.99. What is the ratio of the CO2 emissions (% of total fuel combustion) of United Arab Emirates in 1987 to that in 1988?
Keep it short and to the point. 0.99. What is the ratio of the CO2 emissions (% of total fuel combustion) of Central Europe in 1987 to that in 1989?
Your response must be concise. 0.83. What is the ratio of the CO2 emissions (% of total fuel combustion) of High income: OECD in 1987 to that in 1989?
Provide a succinct answer. 0.97. What is the ratio of the CO2 emissions (% of total fuel combustion) of Brunei Darussalam in 1987 to that in 1989?
Provide a succinct answer. 0.94. What is the ratio of the CO2 emissions (% of total fuel combustion) of United Arab Emirates in 1987 to that in 1989?
Provide a succinct answer. 1.1. What is the ratio of the CO2 emissions (% of total fuel combustion) of Central Europe in 1988 to that in 1989?
Your answer should be compact. 0.87. What is the ratio of the CO2 emissions (% of total fuel combustion) of High income: OECD in 1988 to that in 1989?
Ensure brevity in your answer.  0.99. What is the ratio of the CO2 emissions (% of total fuel combustion) in Brunei Darussalam in 1988 to that in 1989?
Offer a very short reply. 0.96. What is the ratio of the CO2 emissions (% of total fuel combustion) of United Arab Emirates in 1988 to that in 1989?
Make the answer very short. 1.11. What is the difference between the highest and the second highest CO2 emissions (% of total fuel combustion) in Central Europe?
Your answer should be very brief. 0.81. What is the difference between the highest and the second highest CO2 emissions (% of total fuel combustion) in High income: OECD?
Give a very brief answer. 0.25. What is the difference between the highest and the second highest CO2 emissions (% of total fuel combustion) of Brunei Darussalam?
Offer a terse response. 0.75. What is the difference between the highest and the second highest CO2 emissions (% of total fuel combustion) in United Arab Emirates?
Your response must be concise. 4.34. What is the difference between the highest and the lowest CO2 emissions (% of total fuel combustion) in Central Europe?
Provide a succinct answer. 1.4. What is the difference between the highest and the lowest CO2 emissions (% of total fuel combustion) of High income: OECD?
Your answer should be very brief. 1.69. What is the difference between the highest and the lowest CO2 emissions (% of total fuel combustion) in Brunei Darussalam?
Offer a terse response. 3.06. What is the difference between the highest and the lowest CO2 emissions (% of total fuel combustion) in United Arab Emirates?
Offer a terse response. 9.92. 